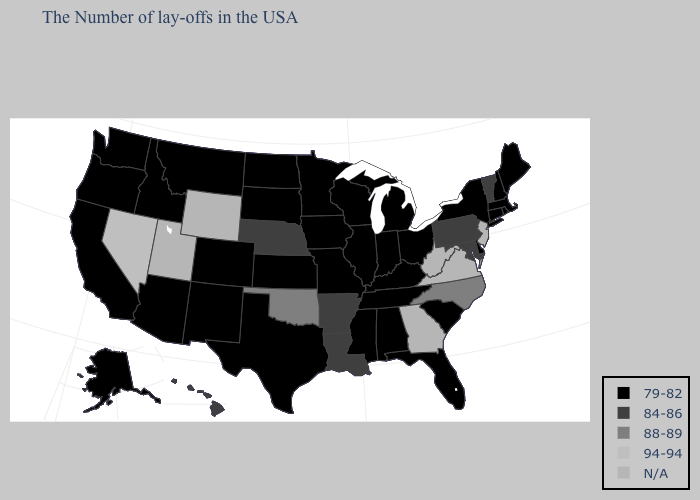What is the value of Hawaii?
Keep it brief. 84-86. Among the states that border Louisiana , which have the highest value?
Give a very brief answer. Arkansas. Which states hav the highest value in the South?
Concise answer only. North Carolina, Oklahoma. Does the first symbol in the legend represent the smallest category?
Give a very brief answer. Yes. Does Nebraska have the lowest value in the USA?
Give a very brief answer. No. What is the value of Oklahoma?
Give a very brief answer. 88-89. Among the states that border Wisconsin , which have the highest value?
Answer briefly. Michigan, Illinois, Minnesota, Iowa. What is the value of Pennsylvania?
Quick response, please. 84-86. What is the highest value in the MidWest ?
Quick response, please. 84-86. What is the highest value in the South ?
Concise answer only. 88-89. What is the value of Massachusetts?
Write a very short answer. 79-82. What is the value of Massachusetts?
Keep it brief. 79-82. Name the states that have a value in the range 88-89?
Be succinct. North Carolina, Oklahoma. Does North Dakota have the lowest value in the USA?
Concise answer only. Yes. 